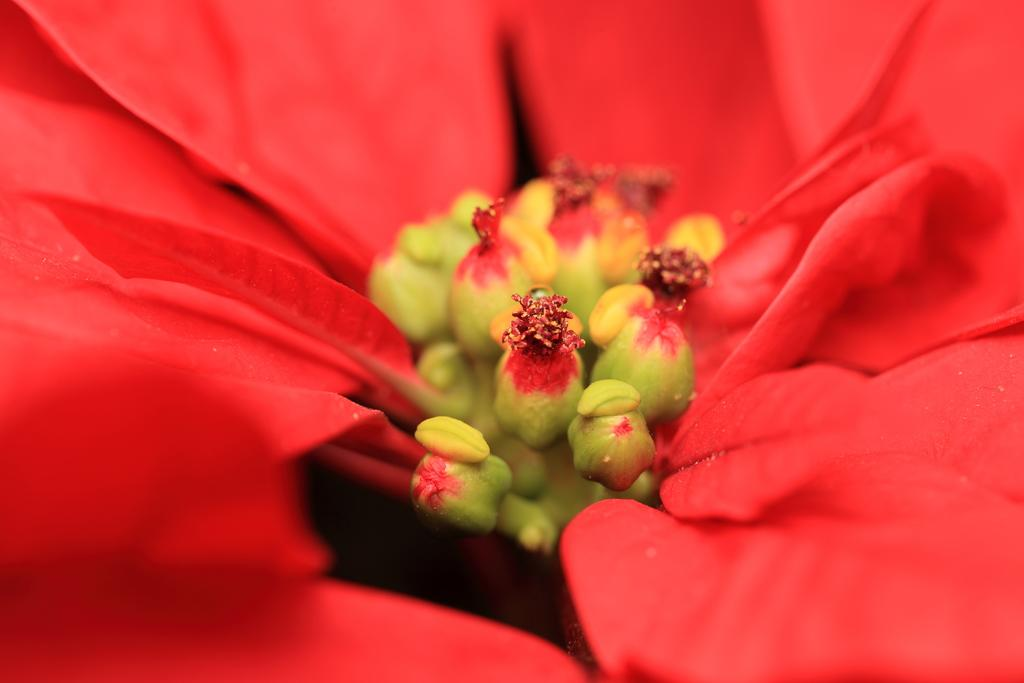What color are the petals in the image? The petals in the image are red-colored. What else in the image shares the same color as the petals? There are red-colored buds in the image. What word is written on the petals in the image? There are no words written on the petals in the image; they are simply red-colored petals and buds. 